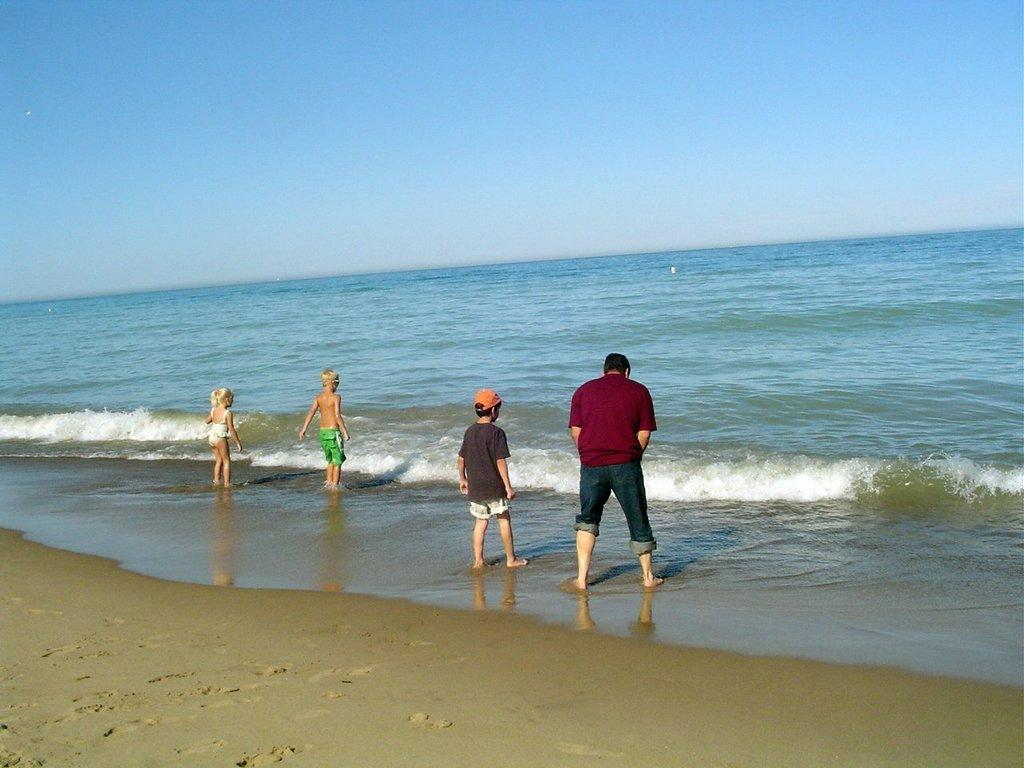What is the surface that the persons are standing on in the image? The persons are standing on the sand in the image. What is the location of the sand in relation to water? The sand is near water in the image. How close are the persons to the water's edge? The persons are standing at the water's edge in the image. What can be seen in the background of the image? There is a sky visible in the background of the image. What type of tooth is visible in the image? There is no tooth present in the image. Is there a sweater being used as a magic carpet in the image? There is no sweater or magic carpet present in the image. 